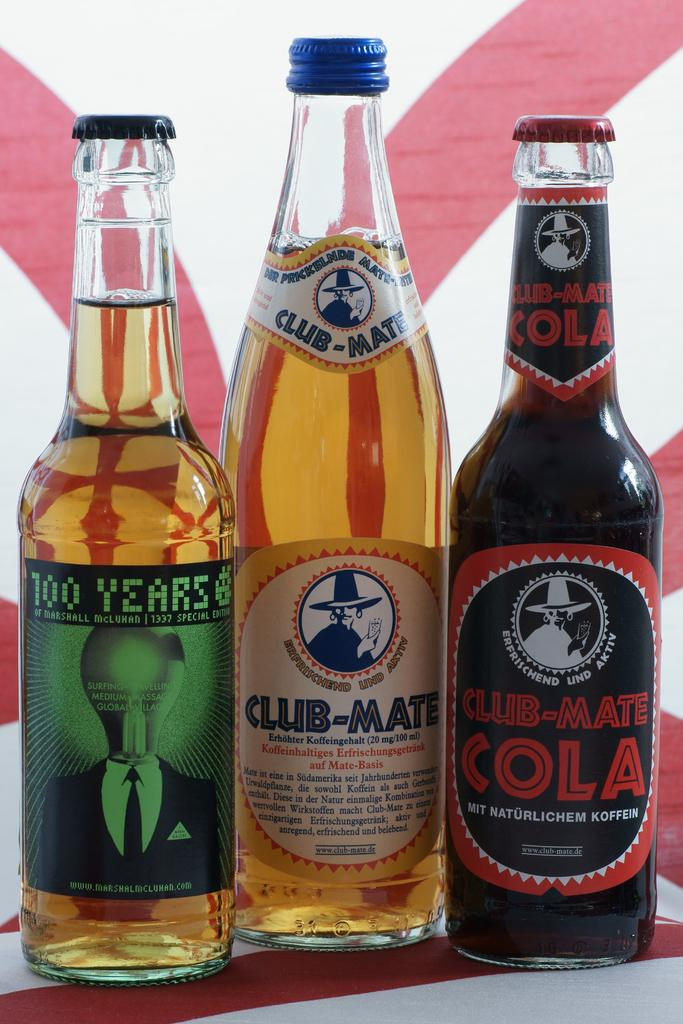<image>
Present a compact description of the photo's key features. A Club-Mate Cola, a Club-Mate, and a 100 Years are all next to each other. 